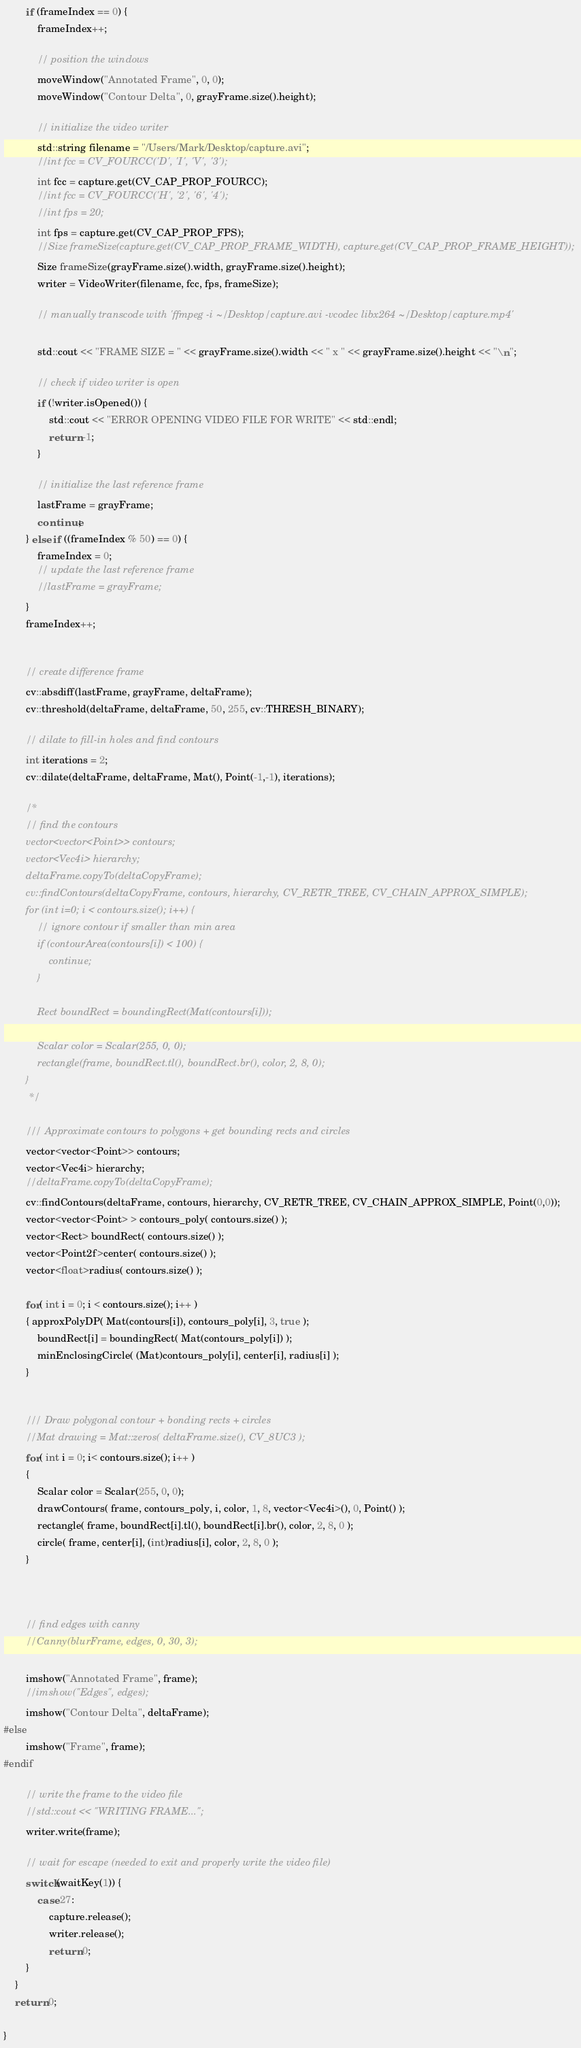Convert code to text. <code><loc_0><loc_0><loc_500><loc_500><_C++_>        if (frameIndex == 0) {
            frameIndex++;

            // position the windows
            moveWindow("Annotated Frame", 0, 0);
            moveWindow("Contour Delta", 0, grayFrame.size().height);

            // initialize the video writer
            std::string filename = "/Users/Mark/Desktop/capture.avi";
            //int fcc = CV_FOURCC('D', 'I', 'V', '3');
            int fcc = capture.get(CV_CAP_PROP_FOURCC);
            //int fcc = CV_FOURCC('H', '2', '6', '4');
            //int fps = 20;
            int fps = capture.get(CV_CAP_PROP_FPS);
            //Size frameSize(capture.get(CV_CAP_PROP_FRAME_WIDTH), capture.get(CV_CAP_PROP_FRAME_HEIGHT));
            Size frameSize(grayFrame.size().width, grayFrame.size().height);
            writer = VideoWriter(filename, fcc, fps, frameSize);

            // manually transcode with 'ffmpeg -i ~/Desktop/capture.avi -vcodec libx264 ~/Desktop/capture.mp4'

            std::cout << "FRAME SIZE = " << grayFrame.size().width << " x " << grayFrame.size().height << "\n";

            // check if video writer is open
            if (!writer.isOpened()) {
                std::cout << "ERROR OPENING VIDEO FILE FOR WRITE" << std::endl;
                return -1;
            }

            // initialize the last reference frame
            lastFrame = grayFrame;
            continue;
        } else if ((frameIndex % 50) == 0) {
            frameIndex = 0;
            // update the last reference frame
            //lastFrame = grayFrame;
        }
        frameIndex++;


        // create difference frame
        cv::absdiff(lastFrame, grayFrame, deltaFrame);
        cv::threshold(deltaFrame, deltaFrame, 50, 255, cv::THRESH_BINARY);

        // dilate to fill-in holes and find contours
        int iterations = 2;
        cv::dilate(deltaFrame, deltaFrame, Mat(), Point(-1,-1), iterations);

        /*
        // find the contours
        vector<vector<Point>> contours;
        vector<Vec4i> hierarchy;
        deltaFrame.copyTo(deltaCopyFrame);
        cv::findContours(deltaCopyFrame, contours, hierarchy, CV_RETR_TREE, CV_CHAIN_APPROX_SIMPLE);
        for (int i=0; i < contours.size(); i++) {
            // ignore contour if smaller than min area
            if (contourArea(contours[i]) < 100) {
                continue;
            }

            Rect boundRect = boundingRect(Mat(contours[i]));

            Scalar color = Scalar(255, 0, 0);
            rectangle(frame, boundRect.tl(), boundRect.br(), color, 2, 8, 0);
        }
         */

        /// Approximate contours to polygons + get bounding rects and circles
        vector<vector<Point>> contours;
        vector<Vec4i> hierarchy;
        //deltaFrame.copyTo(deltaCopyFrame);
        cv::findContours(deltaFrame, contours, hierarchy, CV_RETR_TREE, CV_CHAIN_APPROX_SIMPLE, Point(0,0));
        vector<vector<Point> > contours_poly( contours.size() );
        vector<Rect> boundRect( contours.size() );
        vector<Point2f>center( contours.size() );
        vector<float>radius( contours.size() );

        for( int i = 0; i < contours.size(); i++ )
        { approxPolyDP( Mat(contours[i]), contours_poly[i], 3, true );
            boundRect[i] = boundingRect( Mat(contours_poly[i]) );
            minEnclosingCircle( (Mat)contours_poly[i], center[i], radius[i] );
        }


        /// Draw polygonal contour + bonding rects + circles
        //Mat drawing = Mat::zeros( deltaFrame.size(), CV_8UC3 );
        for( int i = 0; i< contours.size(); i++ )
        {
            Scalar color = Scalar(255, 0, 0);
            drawContours( frame, contours_poly, i, color, 1, 8, vector<Vec4i>(), 0, Point() );
            rectangle( frame, boundRect[i].tl(), boundRect[i].br(), color, 2, 8, 0 );
            circle( frame, center[i], (int)radius[i], color, 2, 8, 0 );
        }



        // find edges with canny
        //Canny(blurFrame, edges, 0, 30, 3);

        imshow("Annotated Frame", frame);
        //imshow("Edges", edges);
        imshow("Contour Delta", deltaFrame);
#else
        imshow("Frame", frame);
#endif

        // write the frame to the video file
        //std::cout << "WRITING FRAME...";
        writer.write(frame);

        // wait for escape (needed to exit and properly write the video file)
        switch(waitKey(1)) {
            case 27:
                capture.release();
                writer.release();
                return 0;
        }
    }
    return 0;

}
</code> 